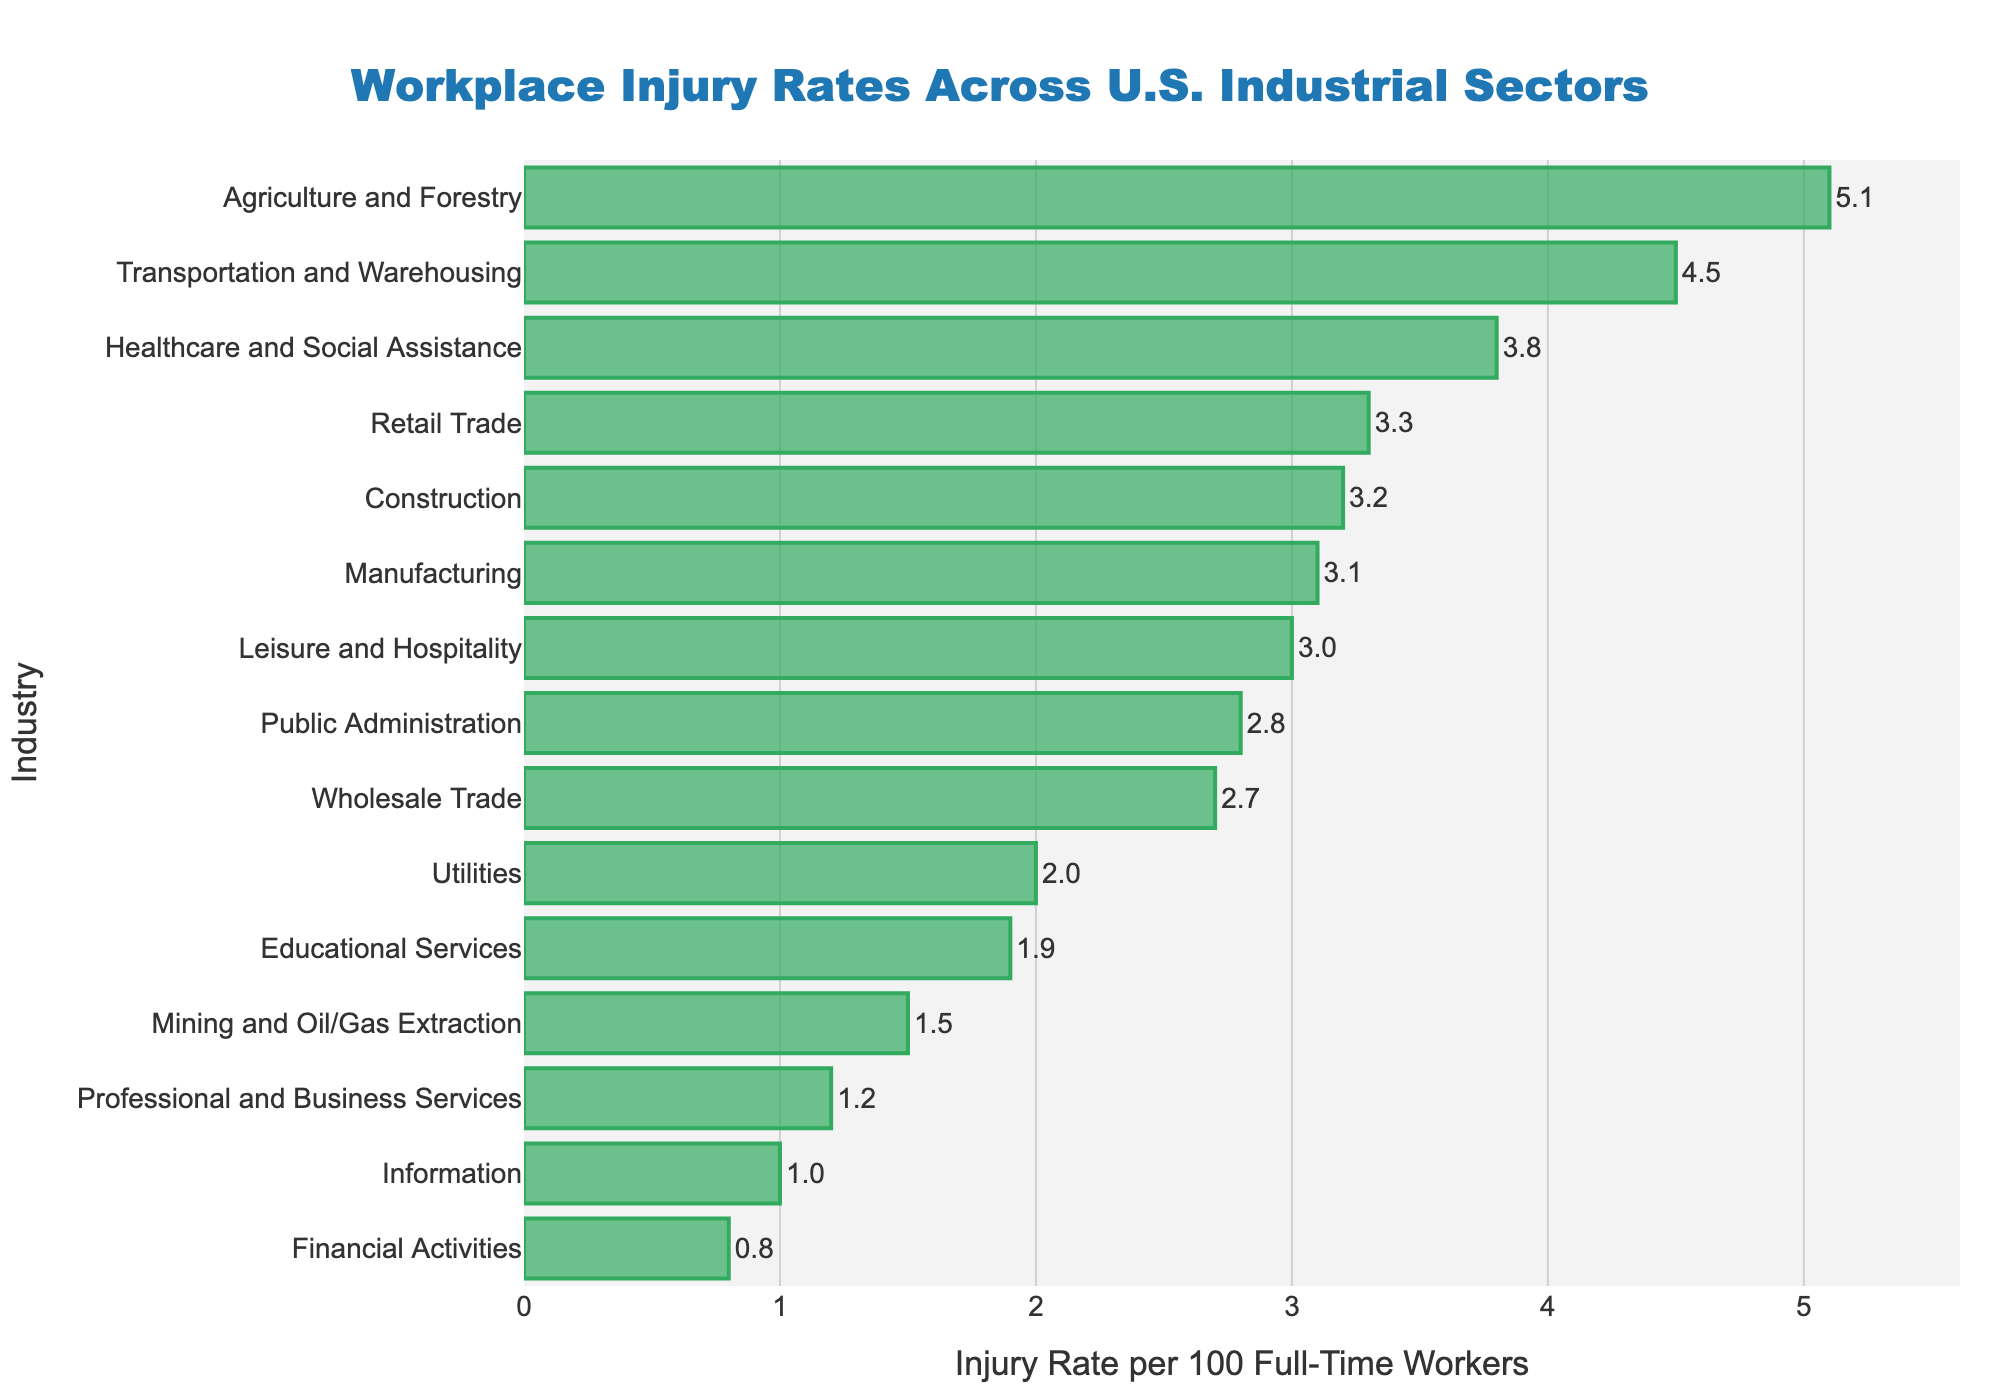Which industry has the highest workplace injury rate? The bar chart shows the workplace injury rates for various industries. The highest bar represents the industry with the highest injury rate, which is Agriculture and Forestry with a rate of 5.1.
Answer: Agriculture and Forestry Which industry has the lowest workplace injury rate? The lowest injury rate is represented by the shortest bar on the chart, which is Financial Activities. Its injury rate is 0.8.
Answer: Financial Activities How do the injury rates of Manufacturing and Wholesale Trade compare? The chart shows the injury rate of Manufacturing is 3.1 and for Wholesale Trade it is 2.7. By comparing these values, we see that the injury rate in Manufacturing is higher than in Wholesale Trade.
Answer: Manufacturing has a higher injury rate How much higher is the injury rate in Transportation and Warehousing compared to Mining and Oil/Gas Extraction? The injury rate in Transportation and Warehousing is 4.5, while in Mining and Oil/Gas Extraction it is 1.5. To find the difference, subtract the smaller rate from the larger one: 4.5 - 1.5 = 3.0.
Answer: 3.0 What is the combined average injury rate of Healthcare and Social Assistance, and Leisure and Hospitality? The injury rates for Healthcare and Social Assistance and Leisure and Hospitality are 3.8 and 3.0, respectively. To find the average, add the two rates and divide by 2: (3.8 + 3.0) / 2 = 3.4.
Answer: 3.4 Which industries have an injury rate greater than 3.0? Observing the heights of the bars, the industries with injury rates greater than 3.0 are Construction (3.2), Healthcare and Social Assistance (3.8), Transportation and Warehousing (4.5), Retail Trade (3.3), and Agriculture and Forestry (5.1).
Answer: Construction, Healthcare and Social Assistance, Transportation and Warehousing, Retail Trade, Agriculture and Forestry What is the difference between the injury rates of the highest and lowest sectors? The highest injury rate is for Agriculture and Forestry (5.1) and the lowest is Financial Activities (0.8). The difference is calculated as 5.1 - 0.8 = 4.3.
Answer: 4.3 How does the injury rate of Utilities compare to that of Educational Services? The injury rate for Utilities is 2.0 and for Educational Services, it is 1.9. By comparing, Utilities has a slightly higher injury rate than Educational Services.
Answer: Utilities has a higher injury rate What is the average injury rate across all industries? Adding all individual injury rates together and then dividing by the number of industries gives the average. The sum is (3.2 + 3.1 + 1.5 + 4.5 + 3.8 + 3.3 + 5.1 + 2.0 + 2.7 + 1.0 + 1.2 + 3.0 + 1.9 + 0.8 + 2.8) = 39.9. Dividing by the number of industries (15) we get, 39.9 / 15 = 2.66.
Answer: 2.66 Which industry is highlighted by the thickest boundary line around the bar? The bar chart uses a thick boundary line around each bar for visual clarity, and all bars have the same thickness in their boundary lines. Hence, no individual industry is highlighted by a thicker boundary line.
Answer: None 